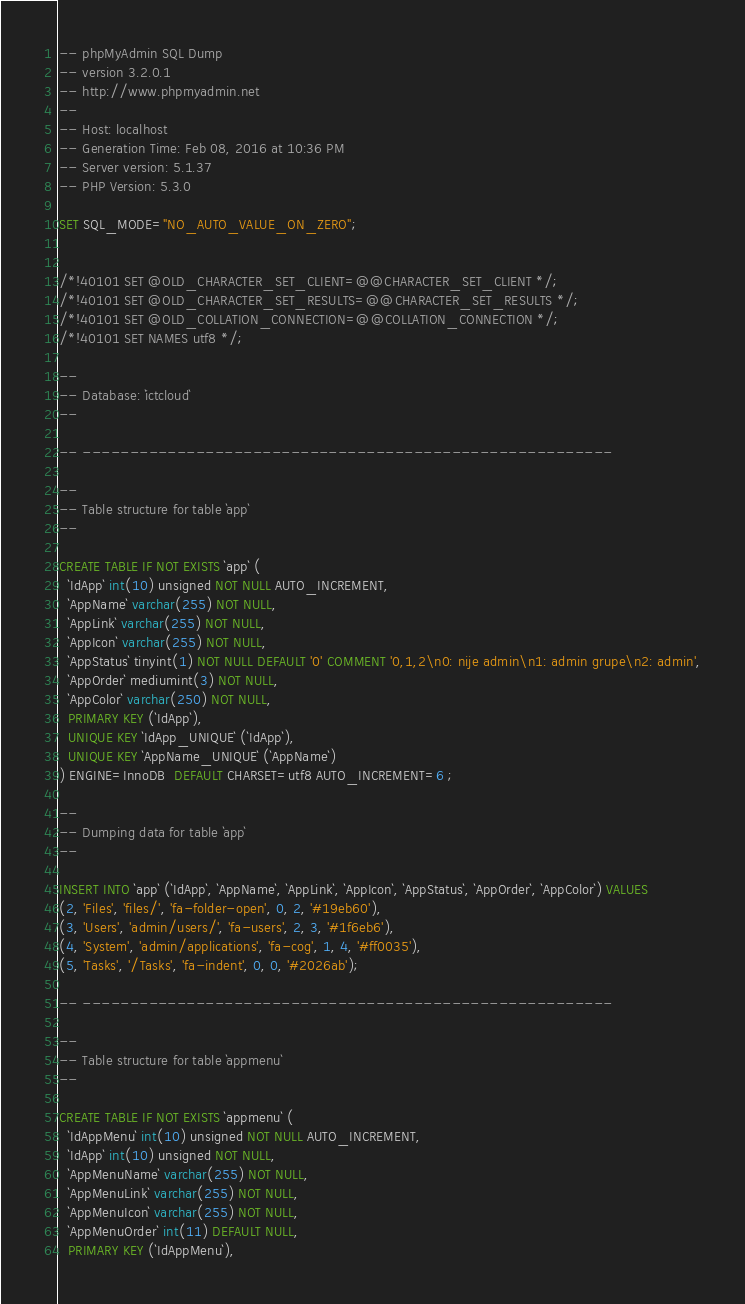<code> <loc_0><loc_0><loc_500><loc_500><_SQL_>-- phpMyAdmin SQL Dump
-- version 3.2.0.1
-- http://www.phpmyadmin.net
--
-- Host: localhost
-- Generation Time: Feb 08, 2016 at 10:36 PM
-- Server version: 5.1.37
-- PHP Version: 5.3.0

SET SQL_MODE="NO_AUTO_VALUE_ON_ZERO";


/*!40101 SET @OLD_CHARACTER_SET_CLIENT=@@CHARACTER_SET_CLIENT */;
/*!40101 SET @OLD_CHARACTER_SET_RESULTS=@@CHARACTER_SET_RESULTS */;
/*!40101 SET @OLD_COLLATION_CONNECTION=@@COLLATION_CONNECTION */;
/*!40101 SET NAMES utf8 */;

--
-- Database: `ictcloud`
--

-- --------------------------------------------------------

--
-- Table structure for table `app`
--

CREATE TABLE IF NOT EXISTS `app` (
  `IdApp` int(10) unsigned NOT NULL AUTO_INCREMENT,
  `AppName` varchar(255) NOT NULL,
  `AppLink` varchar(255) NOT NULL,
  `AppIcon` varchar(255) NOT NULL,
  `AppStatus` tinyint(1) NOT NULL DEFAULT '0' COMMENT '0,1,2\n0: nije admin\n1: admin grupe\n2: admin',
  `AppOrder` mediumint(3) NOT NULL,
  `AppColor` varchar(250) NOT NULL,
  PRIMARY KEY (`IdApp`),
  UNIQUE KEY `IdApp_UNIQUE` (`IdApp`),
  UNIQUE KEY `AppName_UNIQUE` (`AppName`)
) ENGINE=InnoDB  DEFAULT CHARSET=utf8 AUTO_INCREMENT=6 ;

--
-- Dumping data for table `app`
--

INSERT INTO `app` (`IdApp`, `AppName`, `AppLink`, `AppIcon`, `AppStatus`, `AppOrder`, `AppColor`) VALUES
(2, 'Files', 'files/', 'fa-folder-open', 0, 2, '#19eb60'),
(3, 'Users', 'admin/users/', 'fa-users', 2, 3, '#1f6eb6'),
(4, 'System', 'admin/applications', 'fa-cog', 1, 4, '#ff0035'),
(5, 'Tasks', '/Tasks', 'fa-indent', 0, 0, '#2026ab');

-- --------------------------------------------------------

--
-- Table structure for table `appmenu`
--

CREATE TABLE IF NOT EXISTS `appmenu` (
  `IdAppMenu` int(10) unsigned NOT NULL AUTO_INCREMENT,
  `IdApp` int(10) unsigned NOT NULL,
  `AppMenuName` varchar(255) NOT NULL,
  `AppMenuLink` varchar(255) NOT NULL,
  `AppMenuIcon` varchar(255) NOT NULL,
  `AppMenuOrder` int(11) DEFAULT NULL,
  PRIMARY KEY (`IdAppMenu`),</code> 